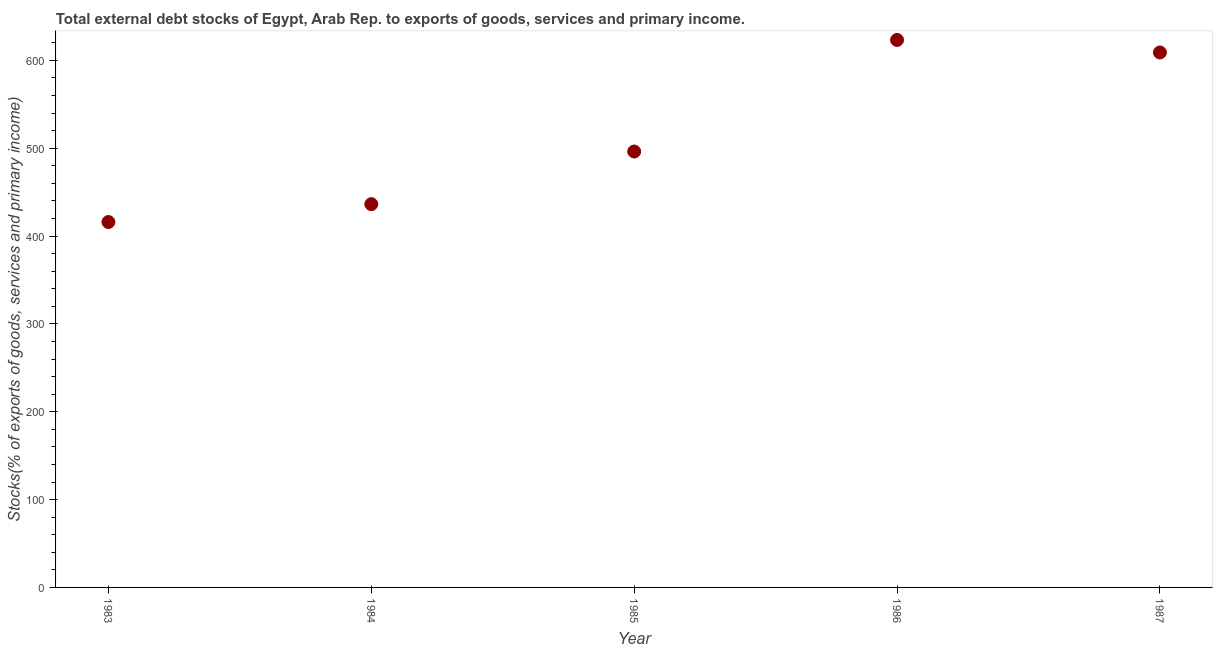What is the external debt stocks in 1986?
Make the answer very short. 623.28. Across all years, what is the maximum external debt stocks?
Make the answer very short. 623.28. Across all years, what is the minimum external debt stocks?
Ensure brevity in your answer.  415.98. In which year was the external debt stocks maximum?
Provide a short and direct response. 1986. What is the sum of the external debt stocks?
Keep it short and to the point. 2580.8. What is the difference between the external debt stocks in 1986 and 1987?
Provide a short and direct response. 14.29. What is the average external debt stocks per year?
Provide a short and direct response. 516.16. What is the median external debt stocks?
Provide a short and direct response. 496.24. In how many years, is the external debt stocks greater than 480 %?
Ensure brevity in your answer.  3. Do a majority of the years between 1987 and 1984 (inclusive) have external debt stocks greater than 380 %?
Give a very brief answer. Yes. What is the ratio of the external debt stocks in 1983 to that in 1987?
Provide a succinct answer. 0.68. Is the difference between the external debt stocks in 1983 and 1985 greater than the difference between any two years?
Provide a short and direct response. No. What is the difference between the highest and the second highest external debt stocks?
Your answer should be compact. 14.29. Is the sum of the external debt stocks in 1984 and 1985 greater than the maximum external debt stocks across all years?
Provide a succinct answer. Yes. What is the difference between the highest and the lowest external debt stocks?
Your answer should be compact. 207.3. How many years are there in the graph?
Ensure brevity in your answer.  5. What is the difference between two consecutive major ticks on the Y-axis?
Provide a short and direct response. 100. Does the graph contain any zero values?
Keep it short and to the point. No. What is the title of the graph?
Give a very brief answer. Total external debt stocks of Egypt, Arab Rep. to exports of goods, services and primary income. What is the label or title of the Y-axis?
Give a very brief answer. Stocks(% of exports of goods, services and primary income). What is the Stocks(% of exports of goods, services and primary income) in 1983?
Offer a terse response. 415.98. What is the Stocks(% of exports of goods, services and primary income) in 1984?
Your answer should be compact. 436.31. What is the Stocks(% of exports of goods, services and primary income) in 1985?
Keep it short and to the point. 496.24. What is the Stocks(% of exports of goods, services and primary income) in 1986?
Your answer should be very brief. 623.28. What is the Stocks(% of exports of goods, services and primary income) in 1987?
Your response must be concise. 608.99. What is the difference between the Stocks(% of exports of goods, services and primary income) in 1983 and 1984?
Ensure brevity in your answer.  -20.33. What is the difference between the Stocks(% of exports of goods, services and primary income) in 1983 and 1985?
Provide a short and direct response. -80.26. What is the difference between the Stocks(% of exports of goods, services and primary income) in 1983 and 1986?
Your answer should be compact. -207.3. What is the difference between the Stocks(% of exports of goods, services and primary income) in 1983 and 1987?
Your answer should be very brief. -193.01. What is the difference between the Stocks(% of exports of goods, services and primary income) in 1984 and 1985?
Your response must be concise. -59.93. What is the difference between the Stocks(% of exports of goods, services and primary income) in 1984 and 1986?
Keep it short and to the point. -186.97. What is the difference between the Stocks(% of exports of goods, services and primary income) in 1984 and 1987?
Your response must be concise. -172.68. What is the difference between the Stocks(% of exports of goods, services and primary income) in 1985 and 1986?
Your answer should be very brief. -127.04. What is the difference between the Stocks(% of exports of goods, services and primary income) in 1985 and 1987?
Ensure brevity in your answer.  -112.75. What is the difference between the Stocks(% of exports of goods, services and primary income) in 1986 and 1987?
Your answer should be very brief. 14.29. What is the ratio of the Stocks(% of exports of goods, services and primary income) in 1983 to that in 1984?
Provide a succinct answer. 0.95. What is the ratio of the Stocks(% of exports of goods, services and primary income) in 1983 to that in 1985?
Provide a short and direct response. 0.84. What is the ratio of the Stocks(% of exports of goods, services and primary income) in 1983 to that in 1986?
Your response must be concise. 0.67. What is the ratio of the Stocks(% of exports of goods, services and primary income) in 1983 to that in 1987?
Provide a short and direct response. 0.68. What is the ratio of the Stocks(% of exports of goods, services and primary income) in 1984 to that in 1985?
Your answer should be compact. 0.88. What is the ratio of the Stocks(% of exports of goods, services and primary income) in 1984 to that in 1987?
Give a very brief answer. 0.72. What is the ratio of the Stocks(% of exports of goods, services and primary income) in 1985 to that in 1986?
Make the answer very short. 0.8. What is the ratio of the Stocks(% of exports of goods, services and primary income) in 1985 to that in 1987?
Your answer should be very brief. 0.81. What is the ratio of the Stocks(% of exports of goods, services and primary income) in 1986 to that in 1987?
Offer a very short reply. 1.02. 